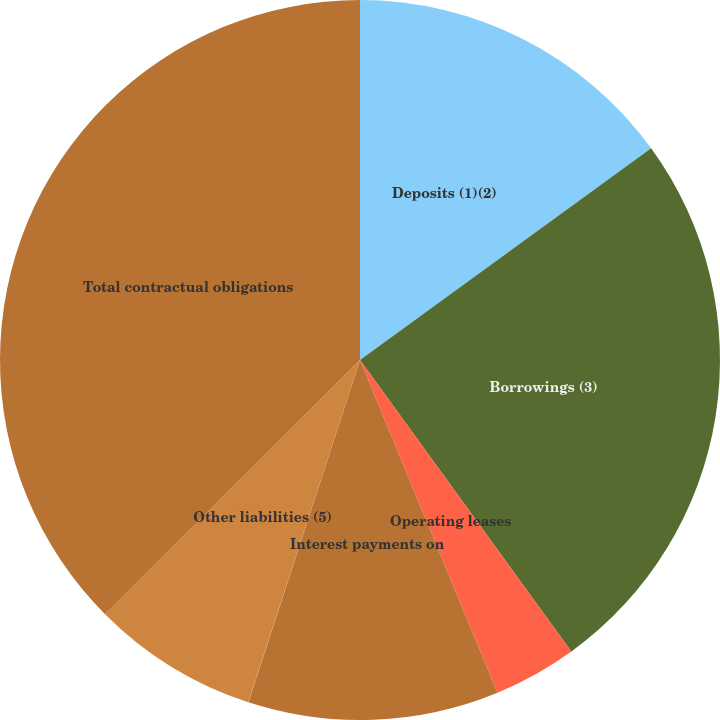<chart> <loc_0><loc_0><loc_500><loc_500><pie_chart><fcel>Deposits (1)(2)<fcel>Borrowings (3)<fcel>Operating leases<fcel>Interest payments on<fcel>Purchase obligations (4)<fcel>Other liabilities (5)<fcel>Total contractual obligations<nl><fcel>14.99%<fcel>25.02%<fcel>3.75%<fcel>11.25%<fcel>0.01%<fcel>7.5%<fcel>37.47%<nl></chart> 